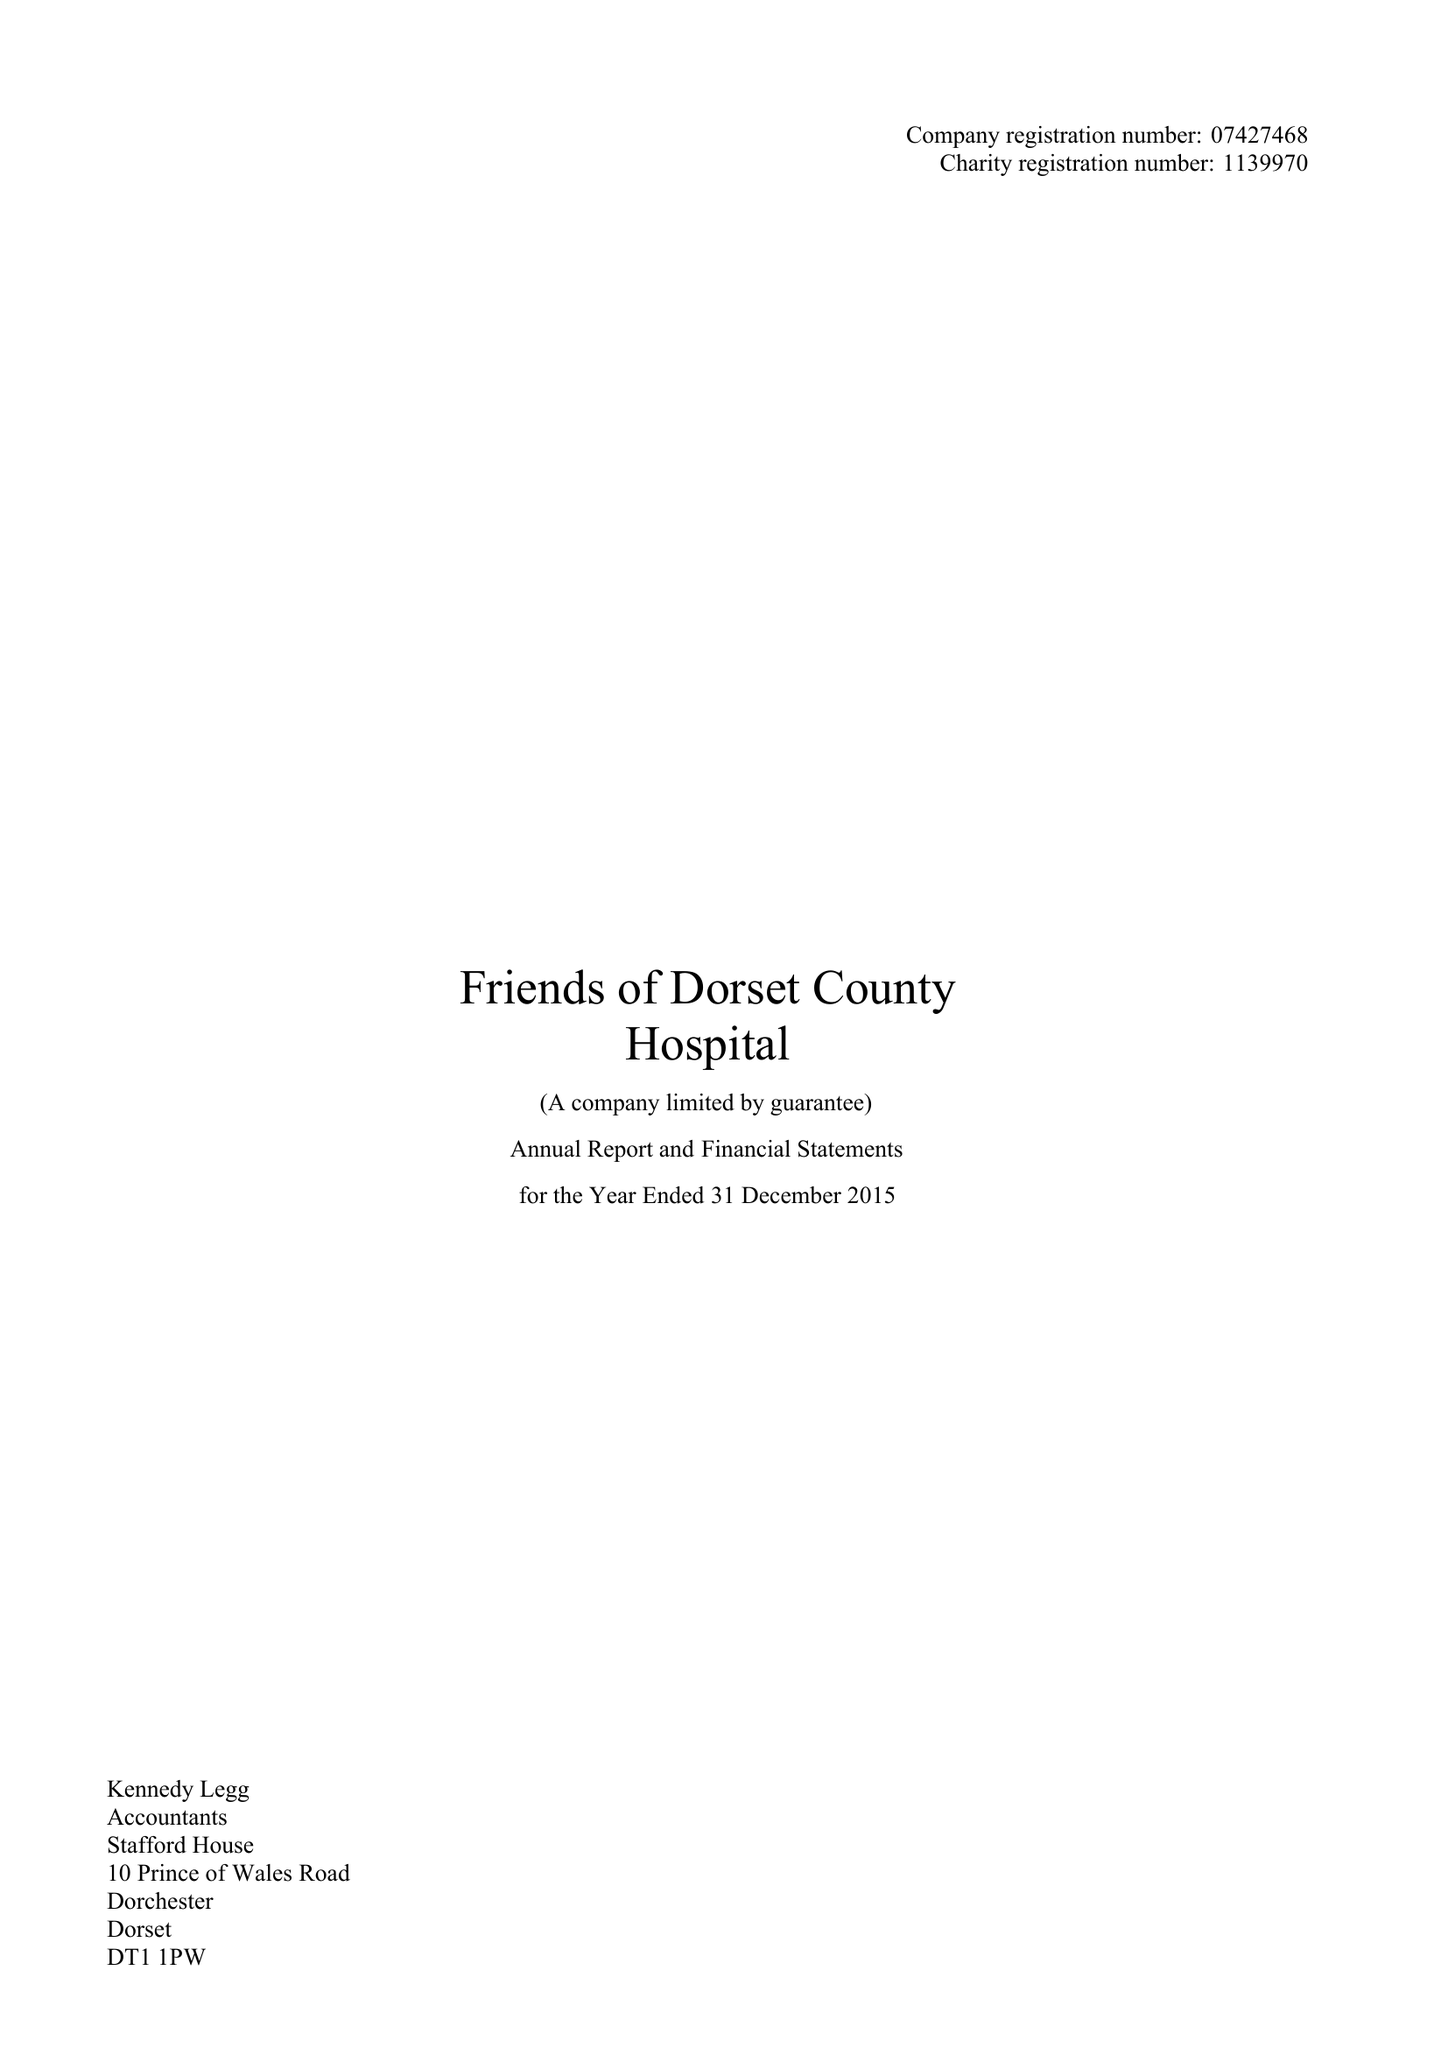What is the value for the address__post_town?
Answer the question using a single word or phrase. DORCHESTER 